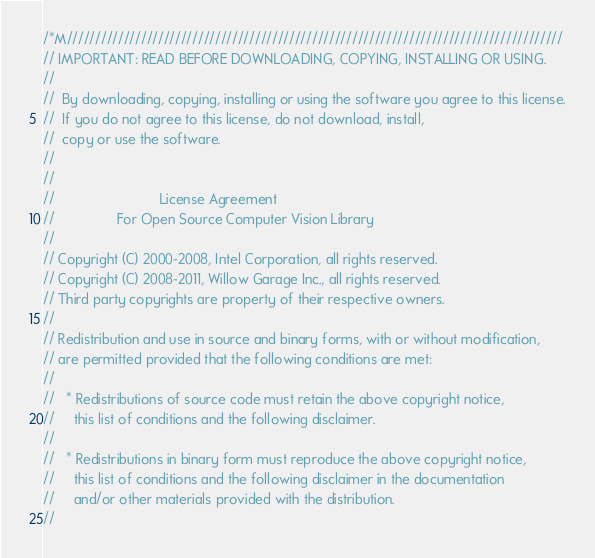Convert code to text. <code><loc_0><loc_0><loc_500><loc_500><_C++_>/*M///////////////////////////////////////////////////////////////////////////////////////
// IMPORTANT: READ BEFORE DOWNLOADING, COPYING, INSTALLING OR USING.
//
//  By downloading, copying, installing or using the software you agree to this license.
//  If you do not agree to this license, do not download, install,
//  copy or use the software.
//
//
//                           License Agreement
//                For Open Source Computer Vision Library
//
// Copyright (C) 2000-2008, Intel Corporation, all rights reserved.
// Copyright (C) 2008-2011, Willow Garage Inc., all rights reserved.
// Third party copyrights are property of their respective owners.
//
// Redistribution and use in source and binary forms, with or without modification,
// are permitted provided that the following conditions are met:
//
//   * Redistributions of source code must retain the above copyright notice,
//     this list of conditions and the following disclaimer.
//
//   * Redistributions in binary form must reproduce the above copyright notice,
//     this list of conditions and the following disclaimer in the documentation
//     and/or other materials provided with the distribution.
//</code> 